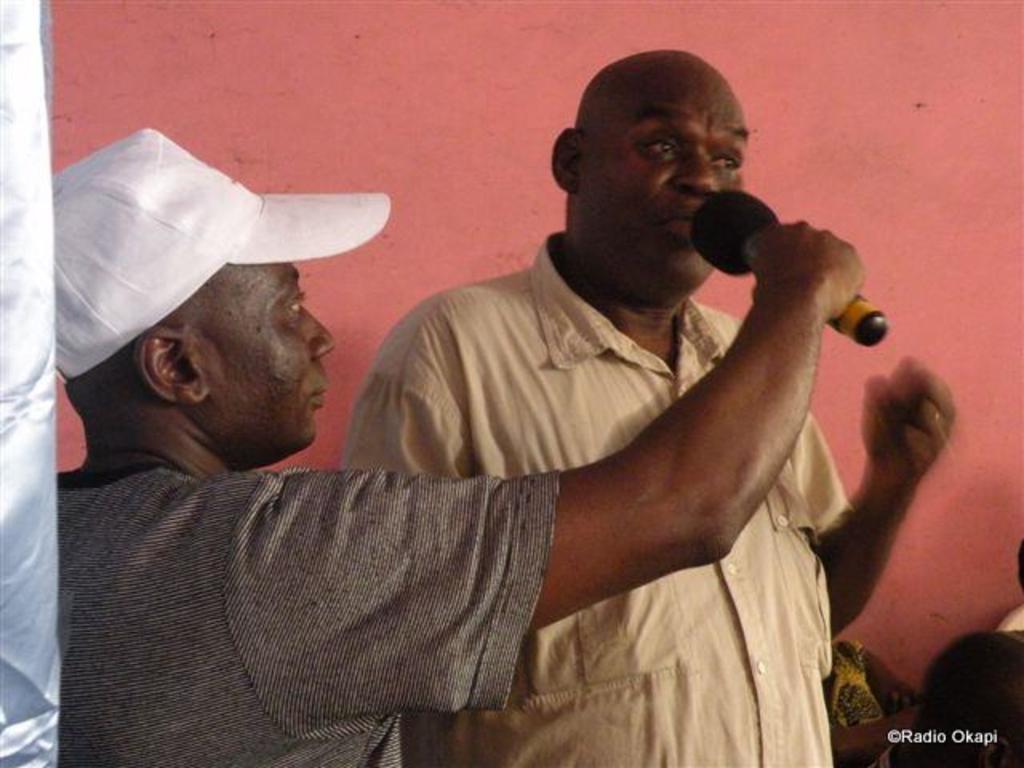Can you describe this image briefly? In the image we can see there are two men who are standing and a man is holding mic in his hand. 